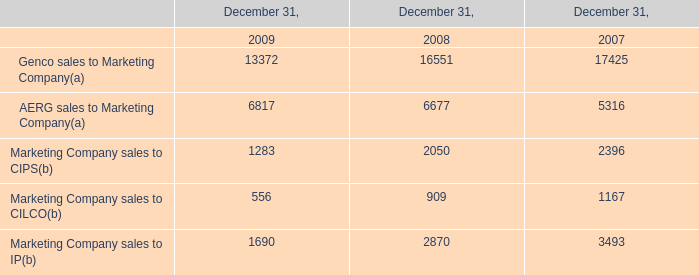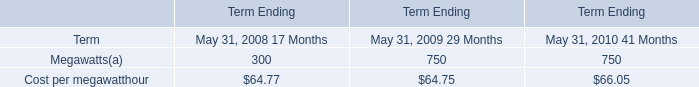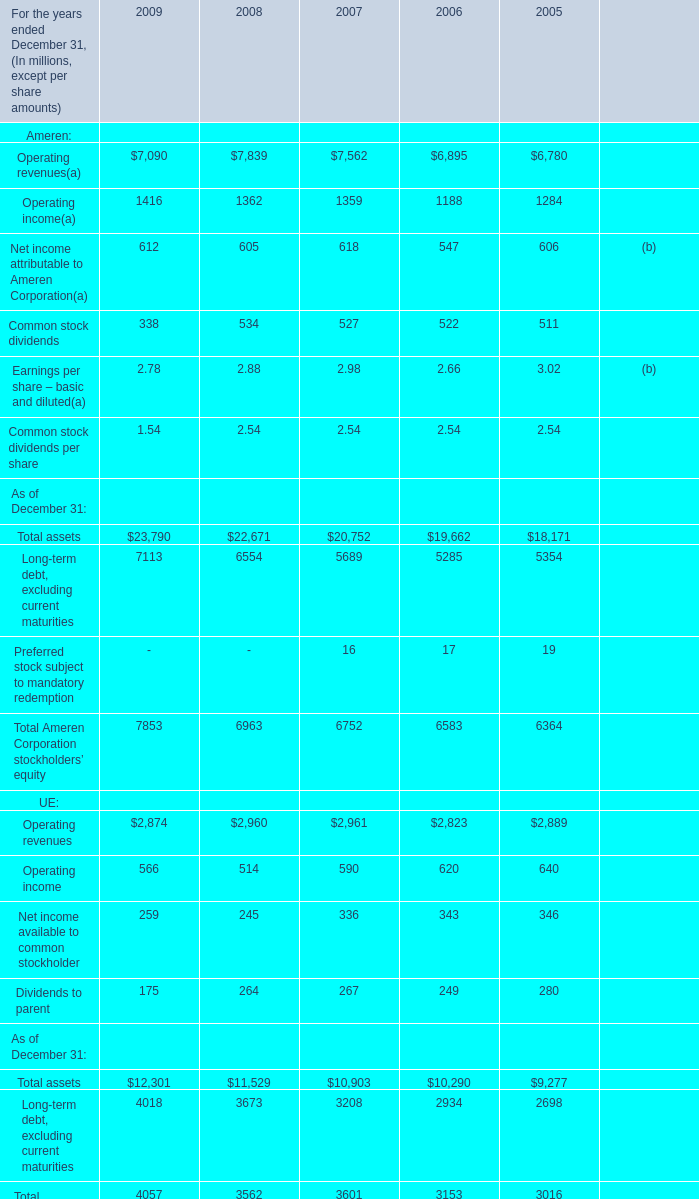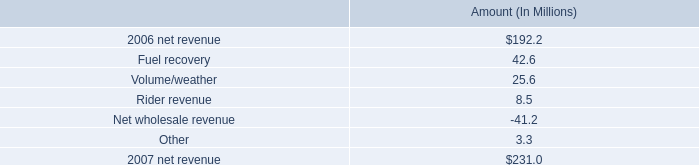what is the percentage change in the number of electric consumers from 2006 to 2007 for entergy new orleans? 
Computations: ((132000 - 95000) / 95000)
Answer: 0.38947. 